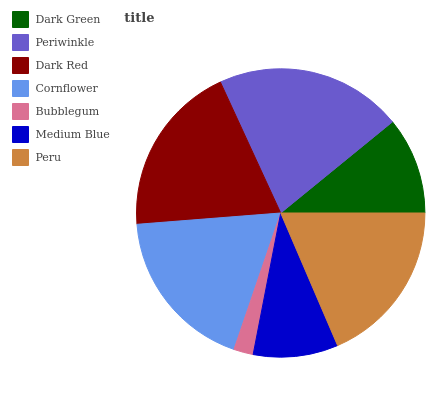Is Bubblegum the minimum?
Answer yes or no. Yes. Is Periwinkle the maximum?
Answer yes or no. Yes. Is Dark Red the minimum?
Answer yes or no. No. Is Dark Red the maximum?
Answer yes or no. No. Is Periwinkle greater than Dark Red?
Answer yes or no. Yes. Is Dark Red less than Periwinkle?
Answer yes or no. Yes. Is Dark Red greater than Periwinkle?
Answer yes or no. No. Is Periwinkle less than Dark Red?
Answer yes or no. No. Is Cornflower the high median?
Answer yes or no. Yes. Is Cornflower the low median?
Answer yes or no. Yes. Is Dark Red the high median?
Answer yes or no. No. Is Medium Blue the low median?
Answer yes or no. No. 